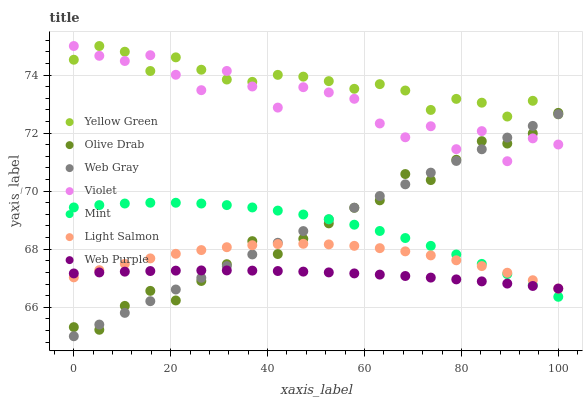Does Web Purple have the minimum area under the curve?
Answer yes or no. Yes. Does Yellow Green have the maximum area under the curve?
Answer yes or no. Yes. Does Web Gray have the minimum area under the curve?
Answer yes or no. No. Does Web Gray have the maximum area under the curve?
Answer yes or no. No. Is Web Gray the smoothest?
Answer yes or no. Yes. Is Violet the roughest?
Answer yes or no. Yes. Is Yellow Green the smoothest?
Answer yes or no. No. Is Yellow Green the roughest?
Answer yes or no. No. Does Web Gray have the lowest value?
Answer yes or no. Yes. Does Yellow Green have the lowest value?
Answer yes or no. No. Does Violet have the highest value?
Answer yes or no. Yes. Does Web Gray have the highest value?
Answer yes or no. No. Is Web Purple less than Violet?
Answer yes or no. Yes. Is Yellow Green greater than Web Purple?
Answer yes or no. Yes. Does Light Salmon intersect Olive Drab?
Answer yes or no. Yes. Is Light Salmon less than Olive Drab?
Answer yes or no. No. Is Light Salmon greater than Olive Drab?
Answer yes or no. No. Does Web Purple intersect Violet?
Answer yes or no. No. 